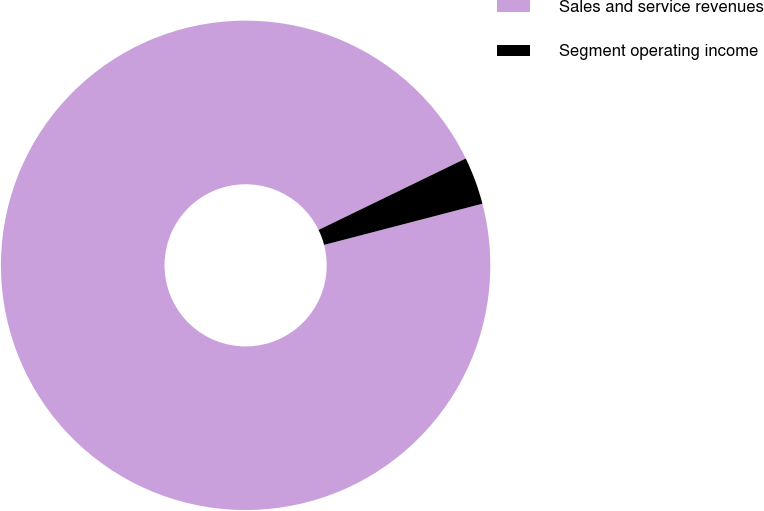<chart> <loc_0><loc_0><loc_500><loc_500><pie_chart><fcel>Sales and service revenues<fcel>Segment operating income<nl><fcel>96.86%<fcel>3.14%<nl></chart> 